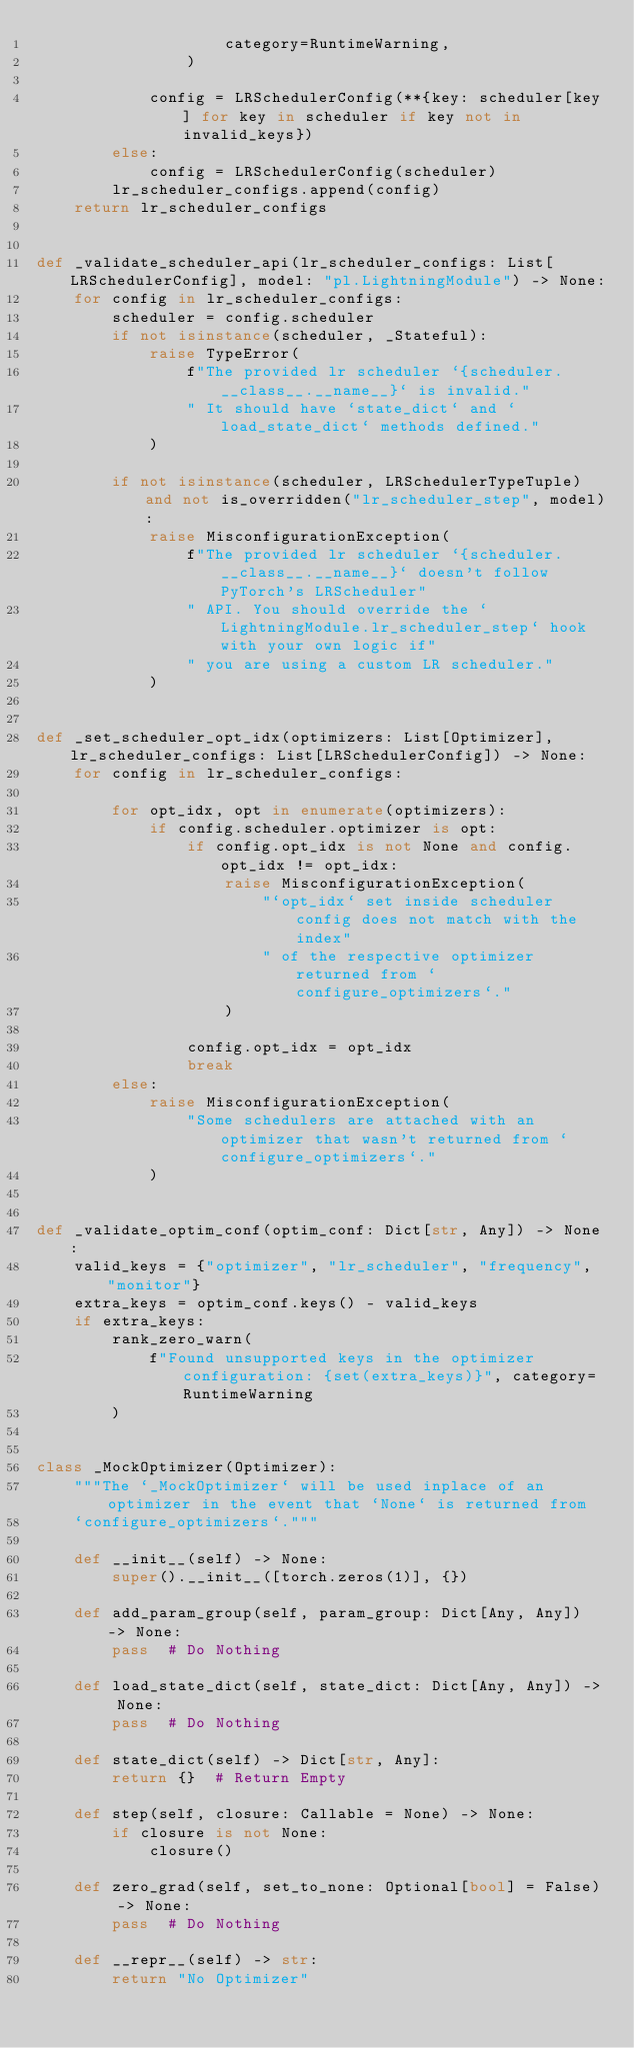<code> <loc_0><loc_0><loc_500><loc_500><_Python_>                    category=RuntimeWarning,
                )

            config = LRSchedulerConfig(**{key: scheduler[key] for key in scheduler if key not in invalid_keys})
        else:
            config = LRSchedulerConfig(scheduler)
        lr_scheduler_configs.append(config)
    return lr_scheduler_configs


def _validate_scheduler_api(lr_scheduler_configs: List[LRSchedulerConfig], model: "pl.LightningModule") -> None:
    for config in lr_scheduler_configs:
        scheduler = config.scheduler
        if not isinstance(scheduler, _Stateful):
            raise TypeError(
                f"The provided lr scheduler `{scheduler.__class__.__name__}` is invalid."
                " It should have `state_dict` and `load_state_dict` methods defined."
            )

        if not isinstance(scheduler, LRSchedulerTypeTuple) and not is_overridden("lr_scheduler_step", model):
            raise MisconfigurationException(
                f"The provided lr scheduler `{scheduler.__class__.__name__}` doesn't follow PyTorch's LRScheduler"
                " API. You should override the `LightningModule.lr_scheduler_step` hook with your own logic if"
                " you are using a custom LR scheduler."
            )


def _set_scheduler_opt_idx(optimizers: List[Optimizer], lr_scheduler_configs: List[LRSchedulerConfig]) -> None:
    for config in lr_scheduler_configs:

        for opt_idx, opt in enumerate(optimizers):
            if config.scheduler.optimizer is opt:
                if config.opt_idx is not None and config.opt_idx != opt_idx:
                    raise MisconfigurationException(
                        "`opt_idx` set inside scheduler config does not match with the index"
                        " of the respective optimizer returned from `configure_optimizers`."
                    )

                config.opt_idx = opt_idx
                break
        else:
            raise MisconfigurationException(
                "Some schedulers are attached with an optimizer that wasn't returned from `configure_optimizers`."
            )


def _validate_optim_conf(optim_conf: Dict[str, Any]) -> None:
    valid_keys = {"optimizer", "lr_scheduler", "frequency", "monitor"}
    extra_keys = optim_conf.keys() - valid_keys
    if extra_keys:
        rank_zero_warn(
            f"Found unsupported keys in the optimizer configuration: {set(extra_keys)}", category=RuntimeWarning
        )


class _MockOptimizer(Optimizer):
    """The `_MockOptimizer` will be used inplace of an optimizer in the event that `None` is returned from
    `configure_optimizers`."""

    def __init__(self) -> None:
        super().__init__([torch.zeros(1)], {})

    def add_param_group(self, param_group: Dict[Any, Any]) -> None:
        pass  # Do Nothing

    def load_state_dict(self, state_dict: Dict[Any, Any]) -> None:
        pass  # Do Nothing

    def state_dict(self) -> Dict[str, Any]:
        return {}  # Return Empty

    def step(self, closure: Callable = None) -> None:
        if closure is not None:
            closure()

    def zero_grad(self, set_to_none: Optional[bool] = False) -> None:
        pass  # Do Nothing

    def __repr__(self) -> str:
        return "No Optimizer"
</code> 